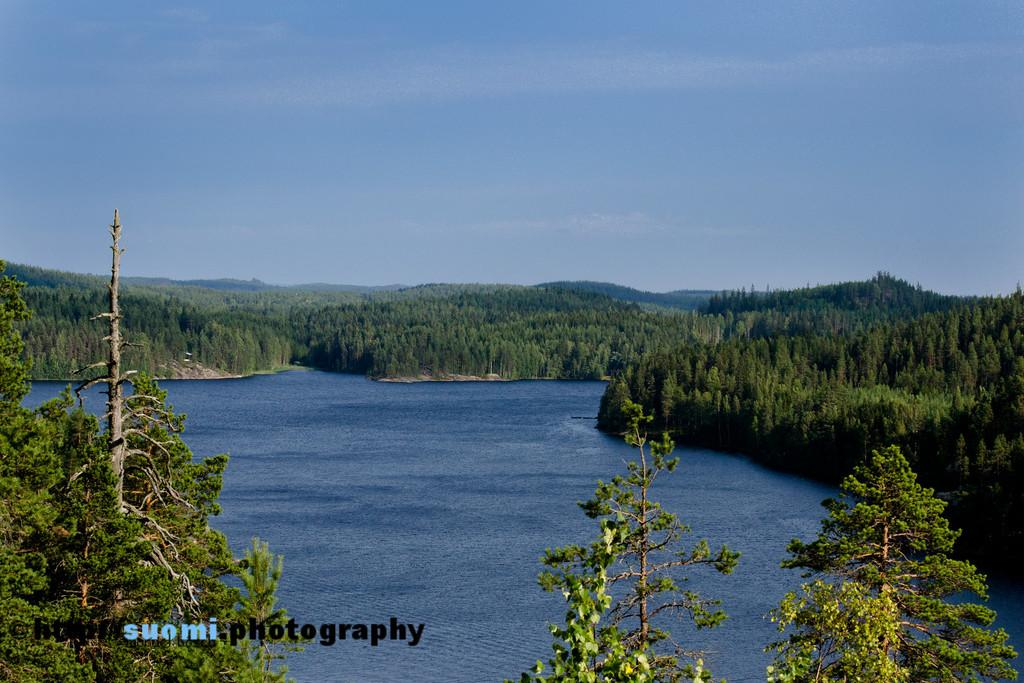What is the primary element visible in the image? There is water in the image. What other natural elements can be seen in the image? There are trees and hills visible in the image. Where is the watermark located in the image? The watermark is in the bottom left side of the image. What can be seen in the background of the image? The sky is visible in the background of the image. What type of muscle is being exercised by the tramp in the image? There is no tramp or muscle present in the image; it features water, trees, hills, and a watermark. 